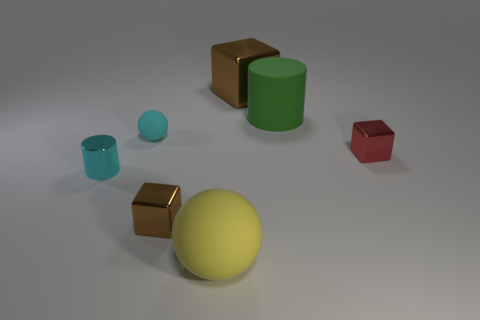Add 1 tiny red cylinders. How many objects exist? 8 Subtract all cylinders. How many objects are left? 5 Subtract 1 yellow spheres. How many objects are left? 6 Subtract all small red matte balls. Subtract all shiny objects. How many objects are left? 3 Add 6 big yellow rubber balls. How many big yellow rubber balls are left? 7 Add 6 small red rubber cubes. How many small red rubber cubes exist? 6 